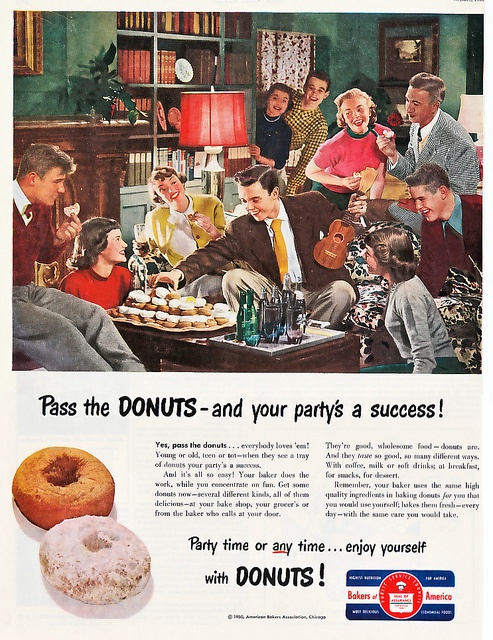Describe the objects in this image and their specific colors. I can see people in ivory, maroon, black, lightgray, and gray tones, people in ivory, gray, maroon, and darkgray tones, book in ivory, maroon, black, and gray tones, people in ivory, darkgray, black, gray, and maroon tones, and couch in ivory, black, gray, and white tones in this image. 